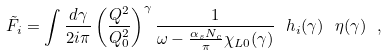Convert formula to latex. <formula><loc_0><loc_0><loc_500><loc_500>\tilde { F } _ { i } = \int \frac { d \gamma } { 2 i \pi } \left ( \frac { Q ^ { 2 } } { Q _ { 0 } ^ { 2 } } \right ) ^ { \gamma } \frac { 1 } { \omega - \frac { \alpha _ { s } N _ { c } } { \pi } \chi _ { L 0 } ( \gamma ) } \ h _ { i } ( \gamma ) \ \eta ( \gamma ) \ ,</formula> 